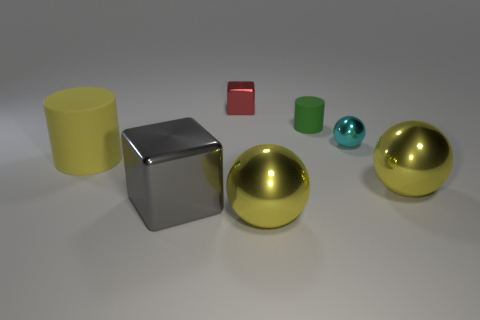Add 1 tiny red metallic balls. How many objects exist? 8 Subtract all spheres. How many objects are left? 4 Subtract all small cyan metallic things. Subtract all tiny metal things. How many objects are left? 4 Add 2 tiny green matte cylinders. How many tiny green matte cylinders are left? 3 Add 5 matte things. How many matte things exist? 7 Subtract 0 red spheres. How many objects are left? 7 